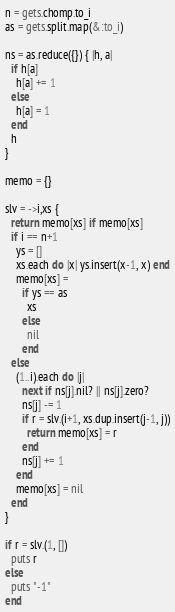Convert code to text. <code><loc_0><loc_0><loc_500><loc_500><_Ruby_>n = gets.chomp.to_i
as = gets.split.map(&:to_i)

ns = as.reduce({}) { |h, a|
  if h[a]
    h[a] += 1
  else
    h[a] = 1
  end
  h
}

memo = {}

slv = ->i,xs {
  return memo[xs] if memo[xs]
  if i == n+1
    ys = []
    xs.each do |x| ys.insert(x-1, x) end
    memo[xs] =
      if ys == as
        xs
      else
        nil
      end
  else
    (1..i).each do |j|
      next if ns[j].nil? || ns[j].zero?
      ns[j] -= 1
      if r = slv.(i+1, xs.dup.insert(j-1, j))
        return memo[xs] = r
      end
      ns[j] += 1
    end
    memo[xs] = nil
  end
}

if r = slv.(1, [])
  puts r
else
  puts "-1"
end</code> 